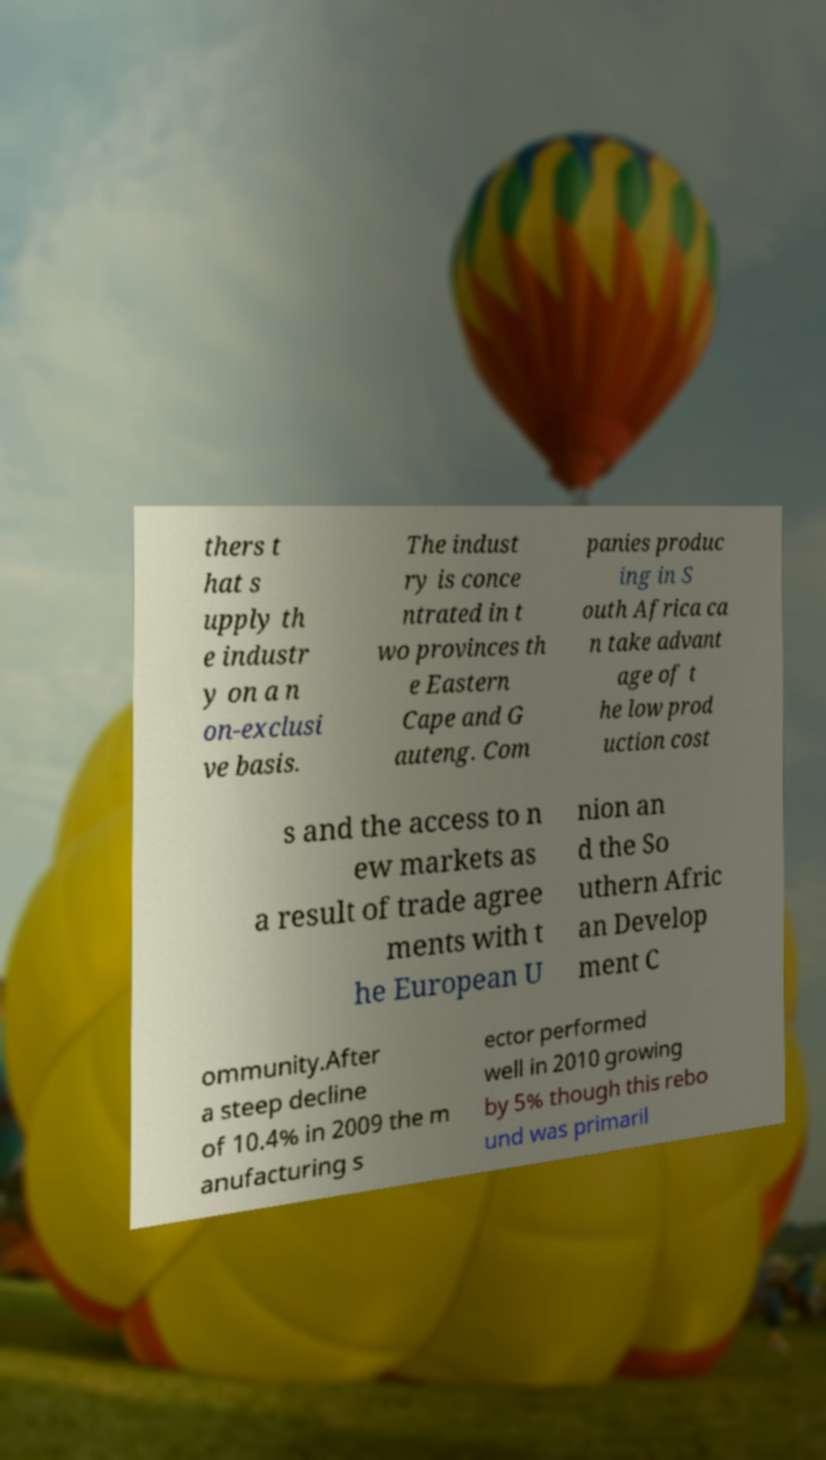There's text embedded in this image that I need extracted. Can you transcribe it verbatim? thers t hat s upply th e industr y on a n on-exclusi ve basis. The indust ry is conce ntrated in t wo provinces th e Eastern Cape and G auteng. Com panies produc ing in S outh Africa ca n take advant age of t he low prod uction cost s and the access to n ew markets as a result of trade agree ments with t he European U nion an d the So uthern Afric an Develop ment C ommunity.After a steep decline of 10.4% in 2009 the m anufacturing s ector performed well in 2010 growing by 5% though this rebo und was primaril 